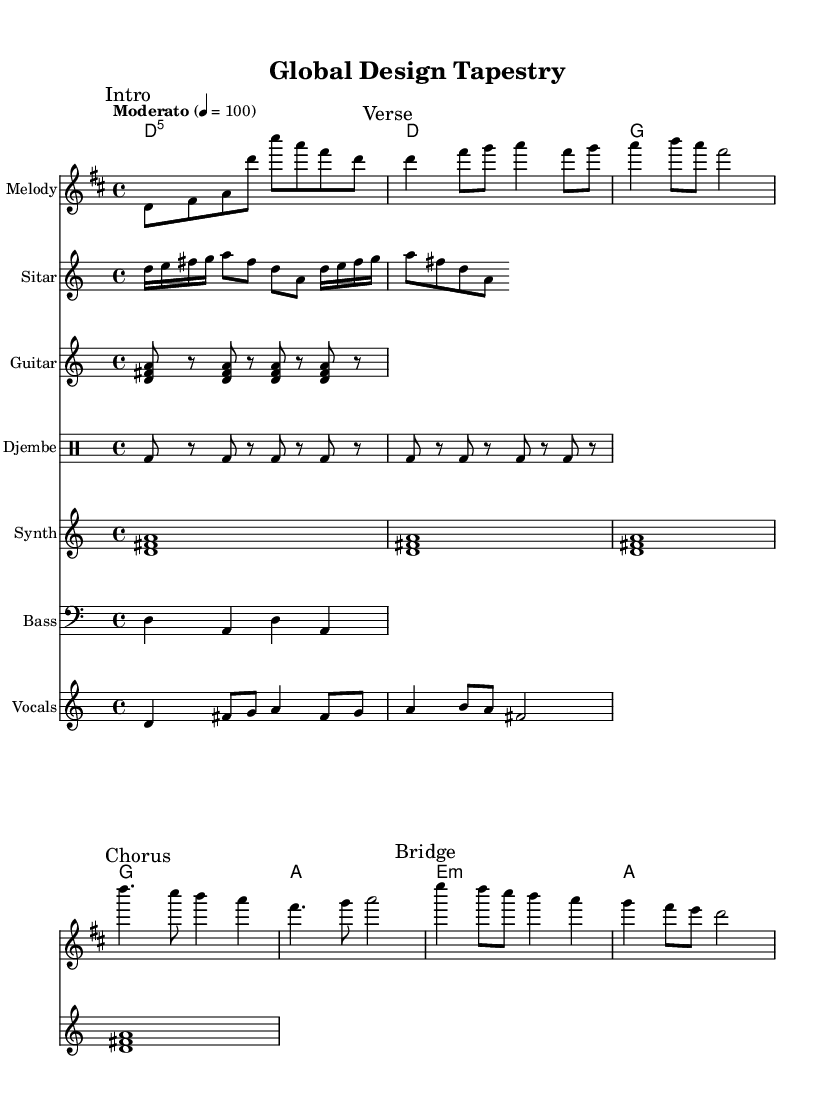What is the key signature of this music? The key signature is D major, indicated by two sharps (F# and C#).
Answer: D major What is the time signature of this music? The time signature is 4/4, which is indicated at the beginning of the score.
Answer: 4/4 What is the tempo marking of this music? The tempo marking is "Moderato," which translates to a moderate speed, noted above the staff.
Answer: Moderato How many phrases are in the melody section? The melody section has three marked phrases: "Intro," "Verse," and "Chorus," seen as separate sections in the sheet music.
Answer: Three What instruments are featured in this score? The score features a melody, sitar, guitar, djembe, synth, bass, and vocals, which are all listed in the score layout.
Answer: Seven Which section of the score features the djembe? The djembe appears under the subsection labelled "Djembe," as noted in the corresponding staff.
Answer: Djembe How does the sitar riff relate to the melody? The sitar riff is an intricate line that complements the melody played in the upper staff, using similar notes and rhythm patterns.
Answer: Complements 